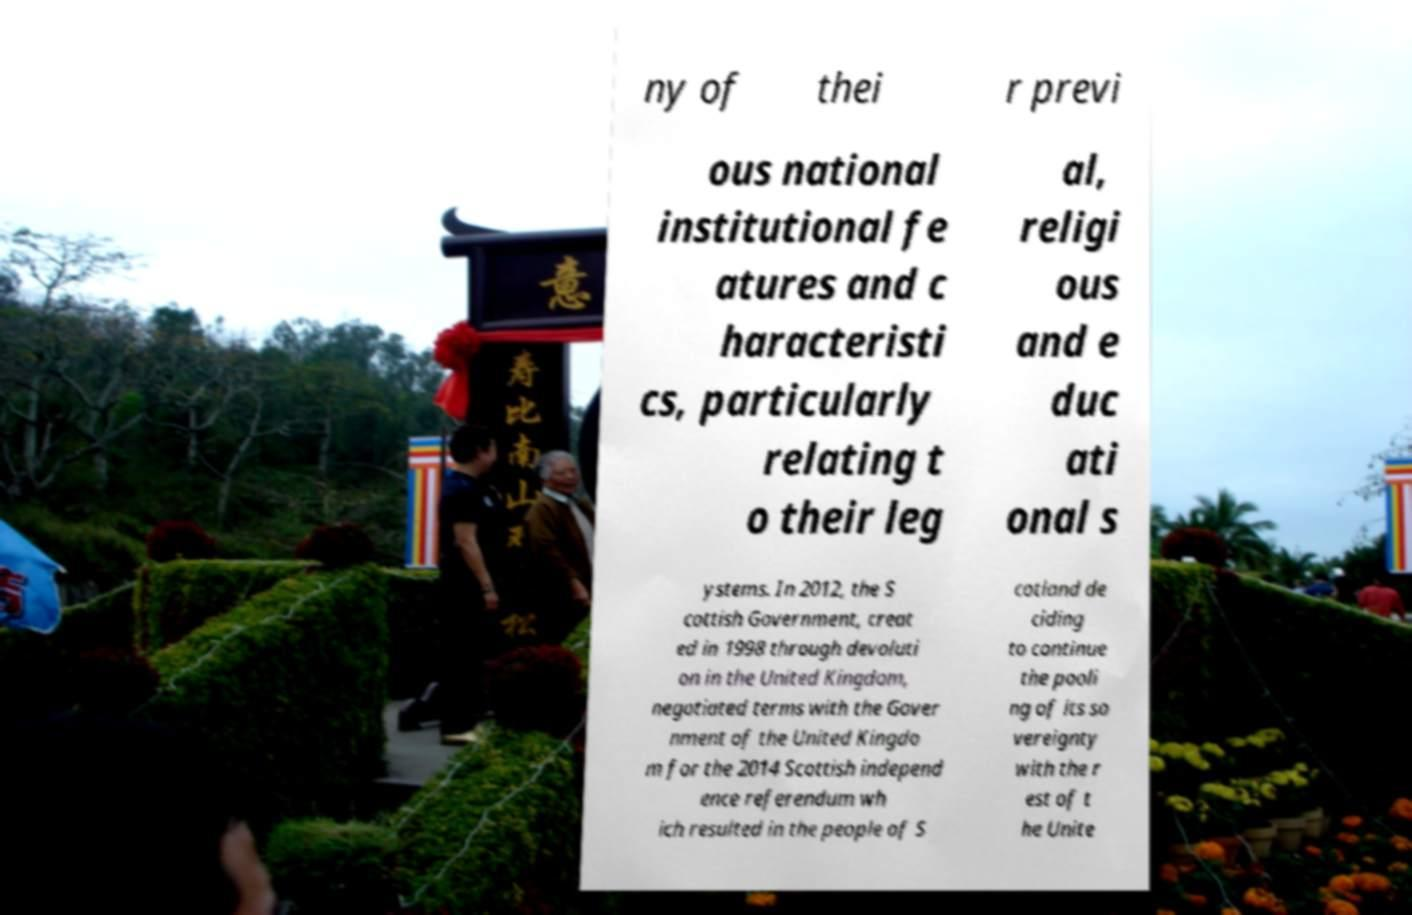Could you extract and type out the text from this image? ny of thei r previ ous national institutional fe atures and c haracteristi cs, particularly relating t o their leg al, religi ous and e duc ati onal s ystems. In 2012, the S cottish Government, creat ed in 1998 through devoluti on in the United Kingdom, negotiated terms with the Gover nment of the United Kingdo m for the 2014 Scottish independ ence referendum wh ich resulted in the people of S cotland de ciding to continue the pooli ng of its so vereignty with the r est of t he Unite 